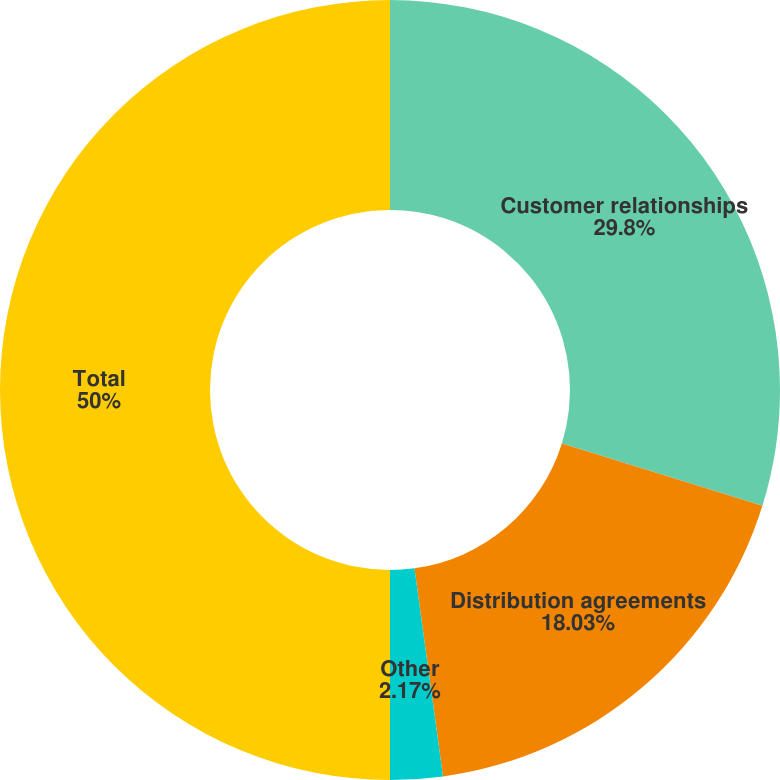Convert chart. <chart><loc_0><loc_0><loc_500><loc_500><pie_chart><fcel>Customer relationships<fcel>Distribution agreements<fcel>Other<fcel>Total<nl><fcel>29.8%<fcel>18.03%<fcel>2.17%<fcel>50.0%<nl></chart> 